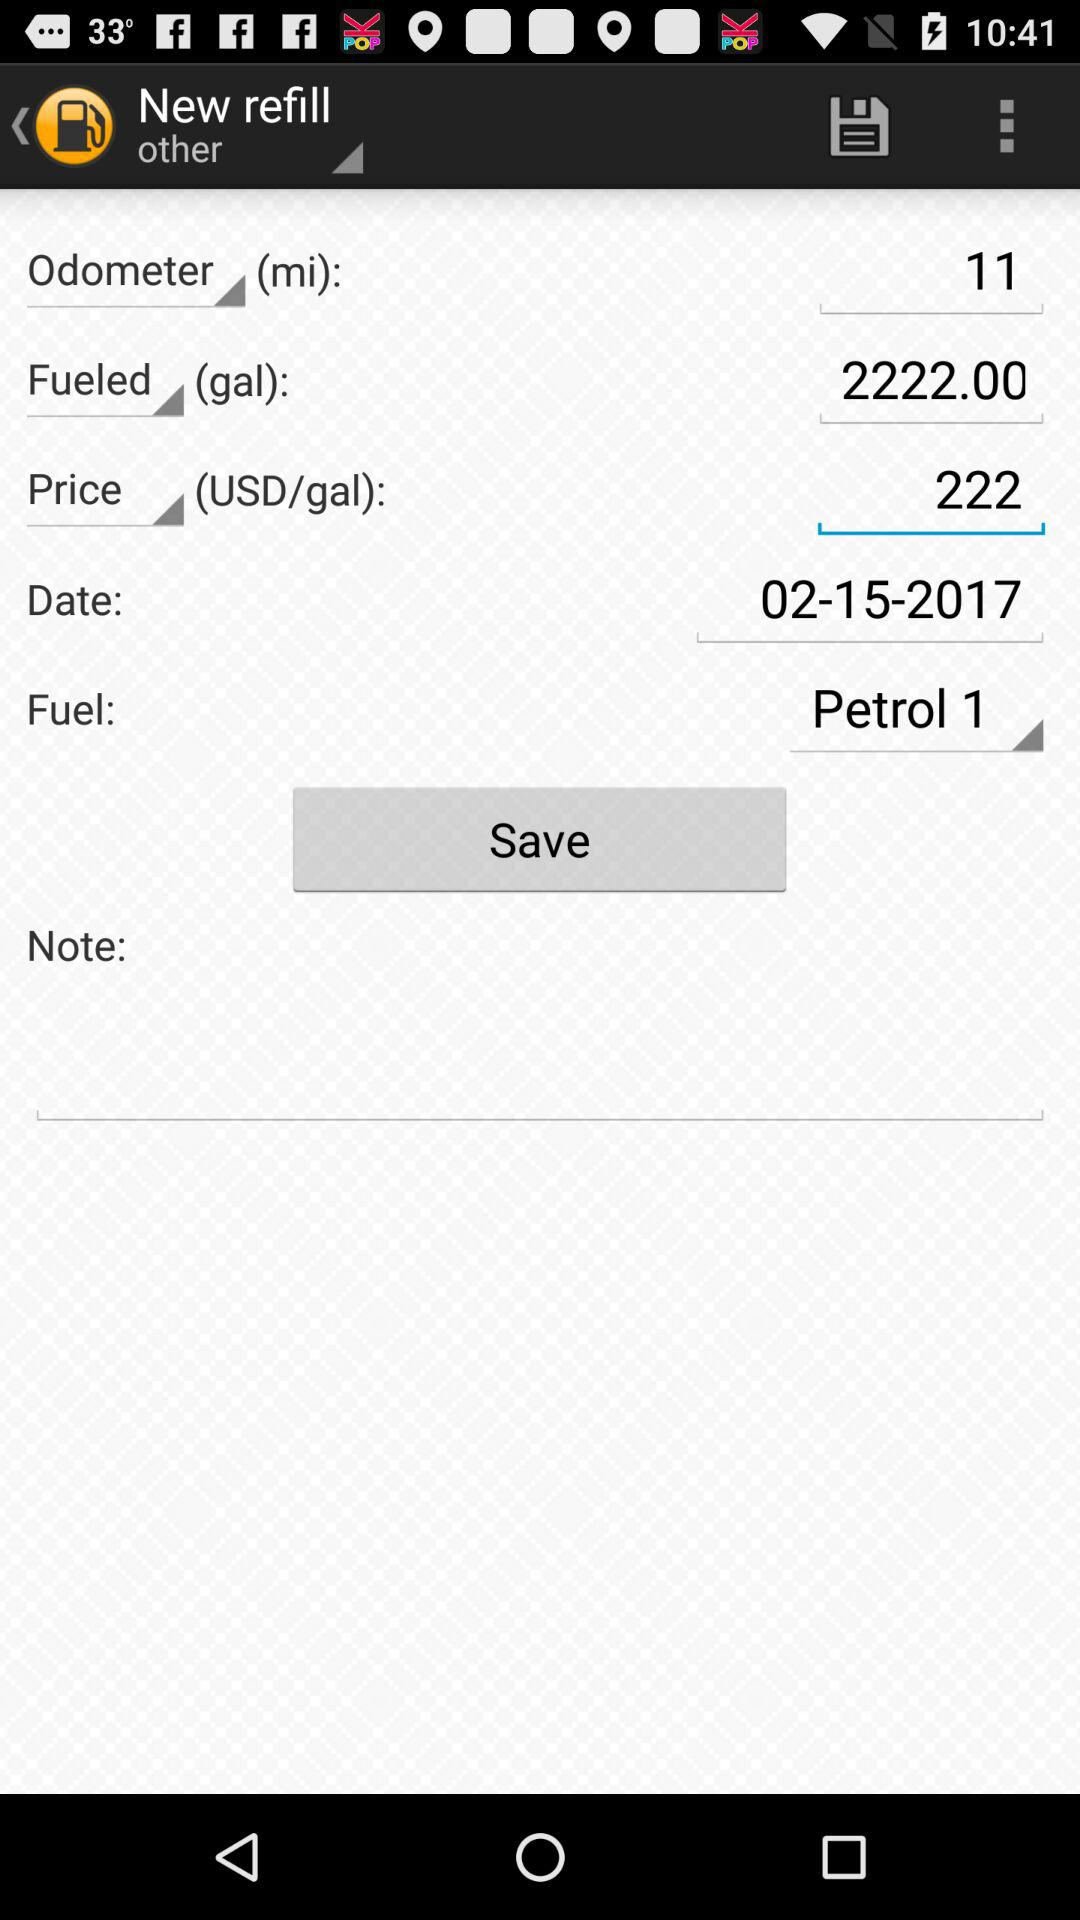What is the date of this refill?
Answer the question using a single word or phrase. 02-15-2017 